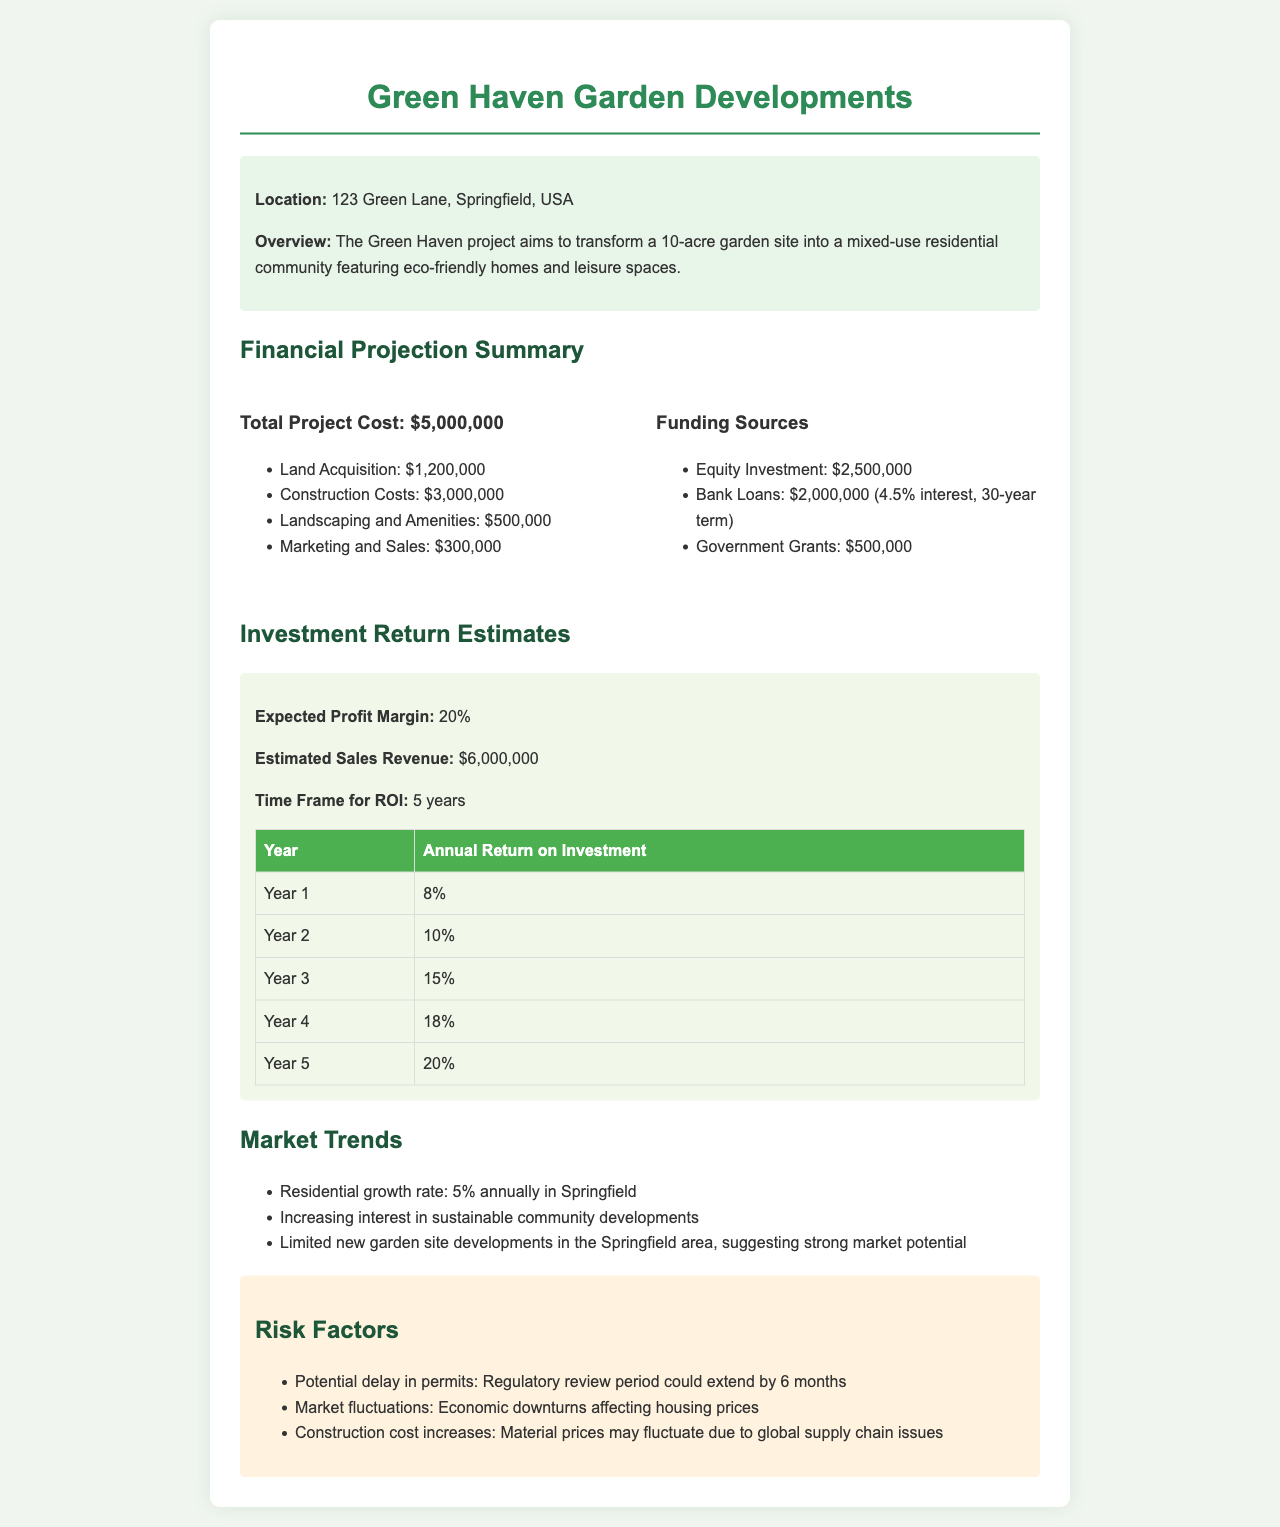What is the total project cost? The total project cost is explicitly stated in the document as the complete financial outlay for the project.
Answer: $5,000,000 What is the expected profit margin? The document directly states the expected profit margin as a percentage of sales revenue, contributing to understanding the financial incentive of the project.
Answer: 20% How much funding is allocated from bank loans? The funding section specifies the exact amount of financing from bank loans, which is a crucial element in assessing funding sources.
Answer: $2,000,000 What is the time frame for ROI? The investment section notes the duration needed to realize returns on the investment, which is vital for evaluating the project's timeline.
Answer: 5 years What are the total landscaping and amenities costs? This amount is specified in the breakdown of total project costs, offering insight into specific expenditures.
Answer: $500,000 What could be a potential risk factor mentioned? The document lists several risk factors, and identifying one helps in understanding challenges faced during development.
Answer: Market fluctuations What is the location of the project? The location is mentioned at the beginning of the document, providing a geographical context to the project.
Answer: 123 Green Lane, Springfield, USA What is the annual return in Year 4? The annual returns are detailed by year, revealing the expected profitability over time.
Answer: 18% What is the estimated sales revenue? The document provides a projection of sales revenue, which is crucial for evaluating the project’s financial viability.
Answer: $6,000,000 How much equity investment is projected? The financing structure includes equity investment, which is important for assessing ownership and risk distribution.
Answer: $2,500,000 